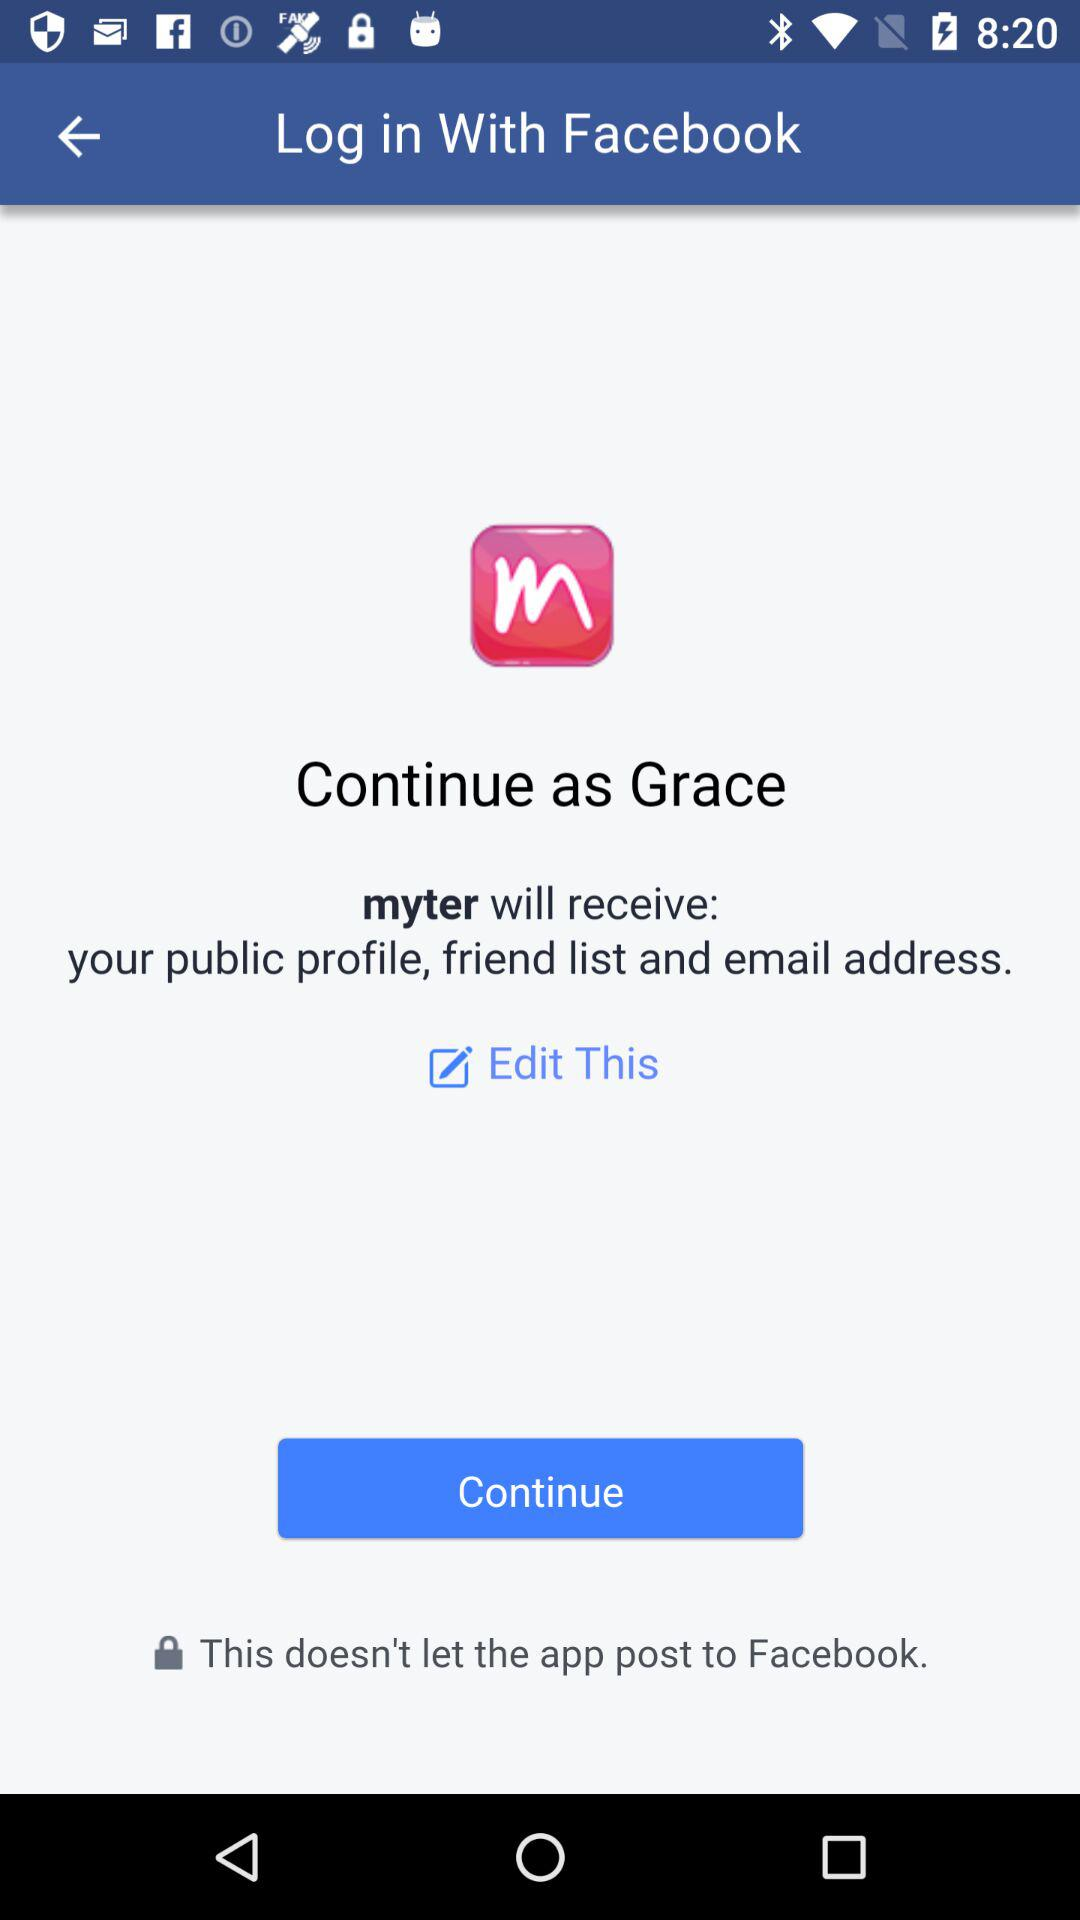What is the user name? The user name is Grace. 